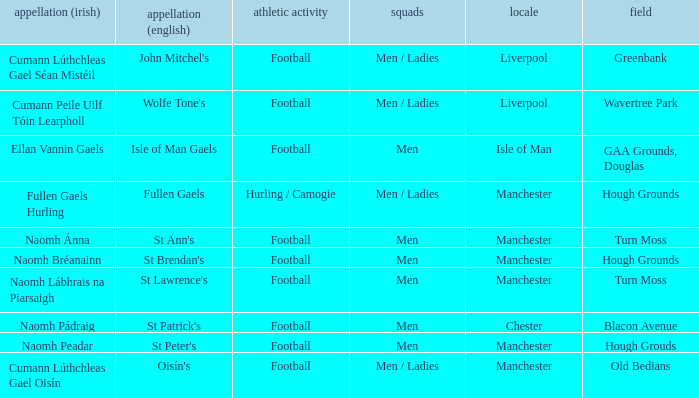What is the Location of the Old Bedians Pitch? Manchester. 